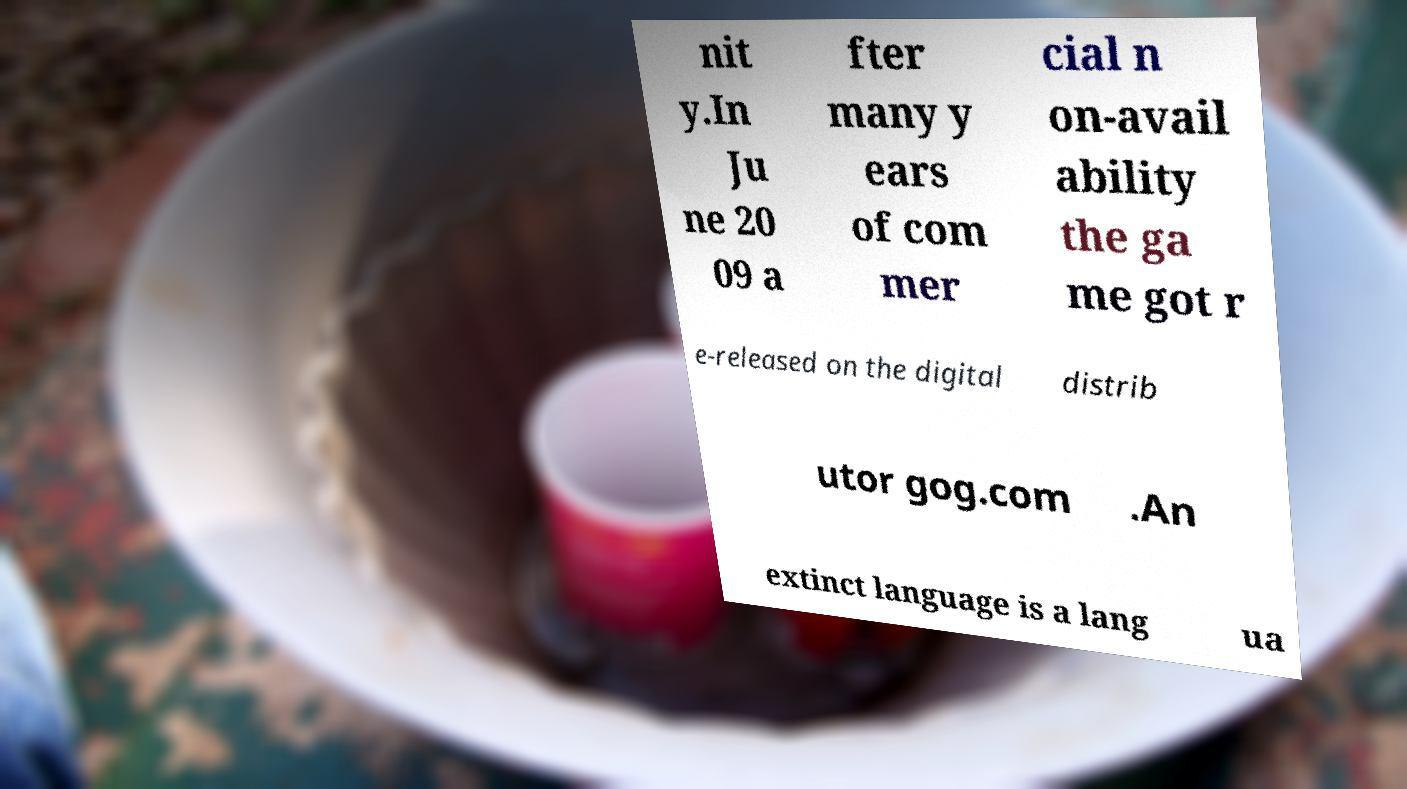Can you read and provide the text displayed in the image?This photo seems to have some interesting text. Can you extract and type it out for me? nit y.In Ju ne 20 09 a fter many y ears of com mer cial n on-avail ability the ga me got r e-released on the digital distrib utor gog.com .An extinct language is a lang ua 